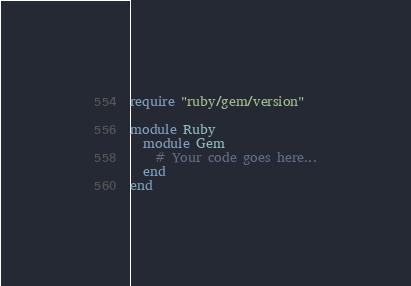<code> <loc_0><loc_0><loc_500><loc_500><_Ruby_>require "ruby/gem/version"

module Ruby
  module Gem
    # Your code goes here...
  end
end
</code> 